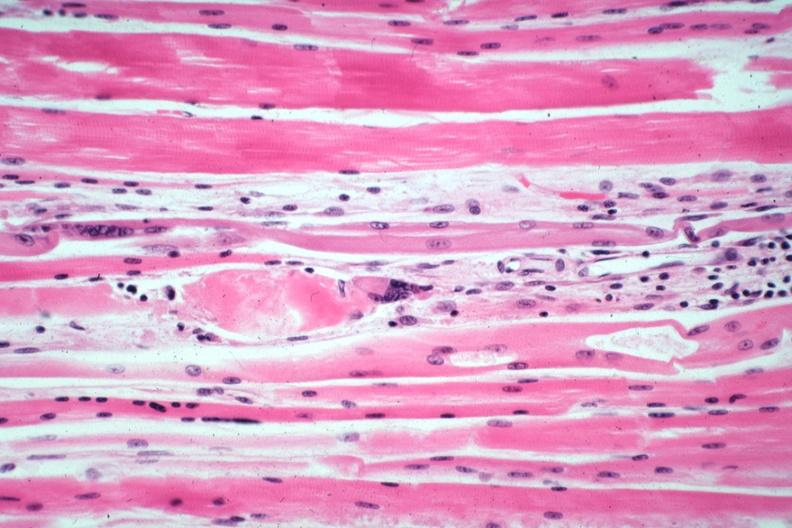what is present?
Answer the question using a single word or phrase. Soft tissue 